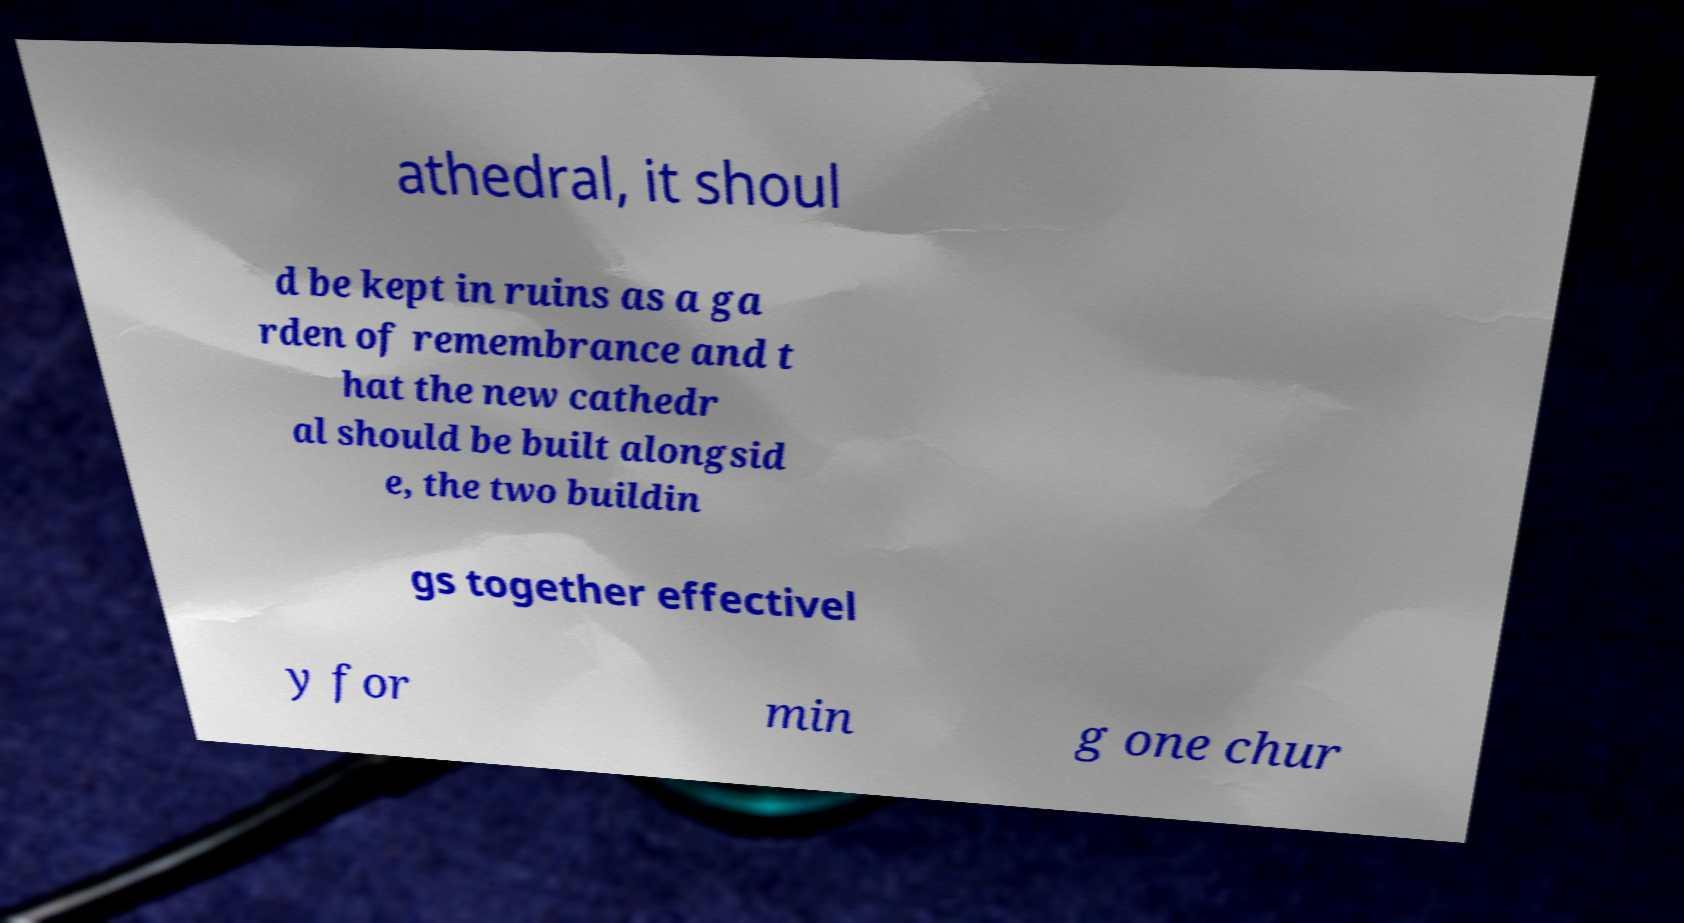I need the written content from this picture converted into text. Can you do that? athedral, it shoul d be kept in ruins as a ga rden of remembrance and t hat the new cathedr al should be built alongsid e, the two buildin gs together effectivel y for min g one chur 